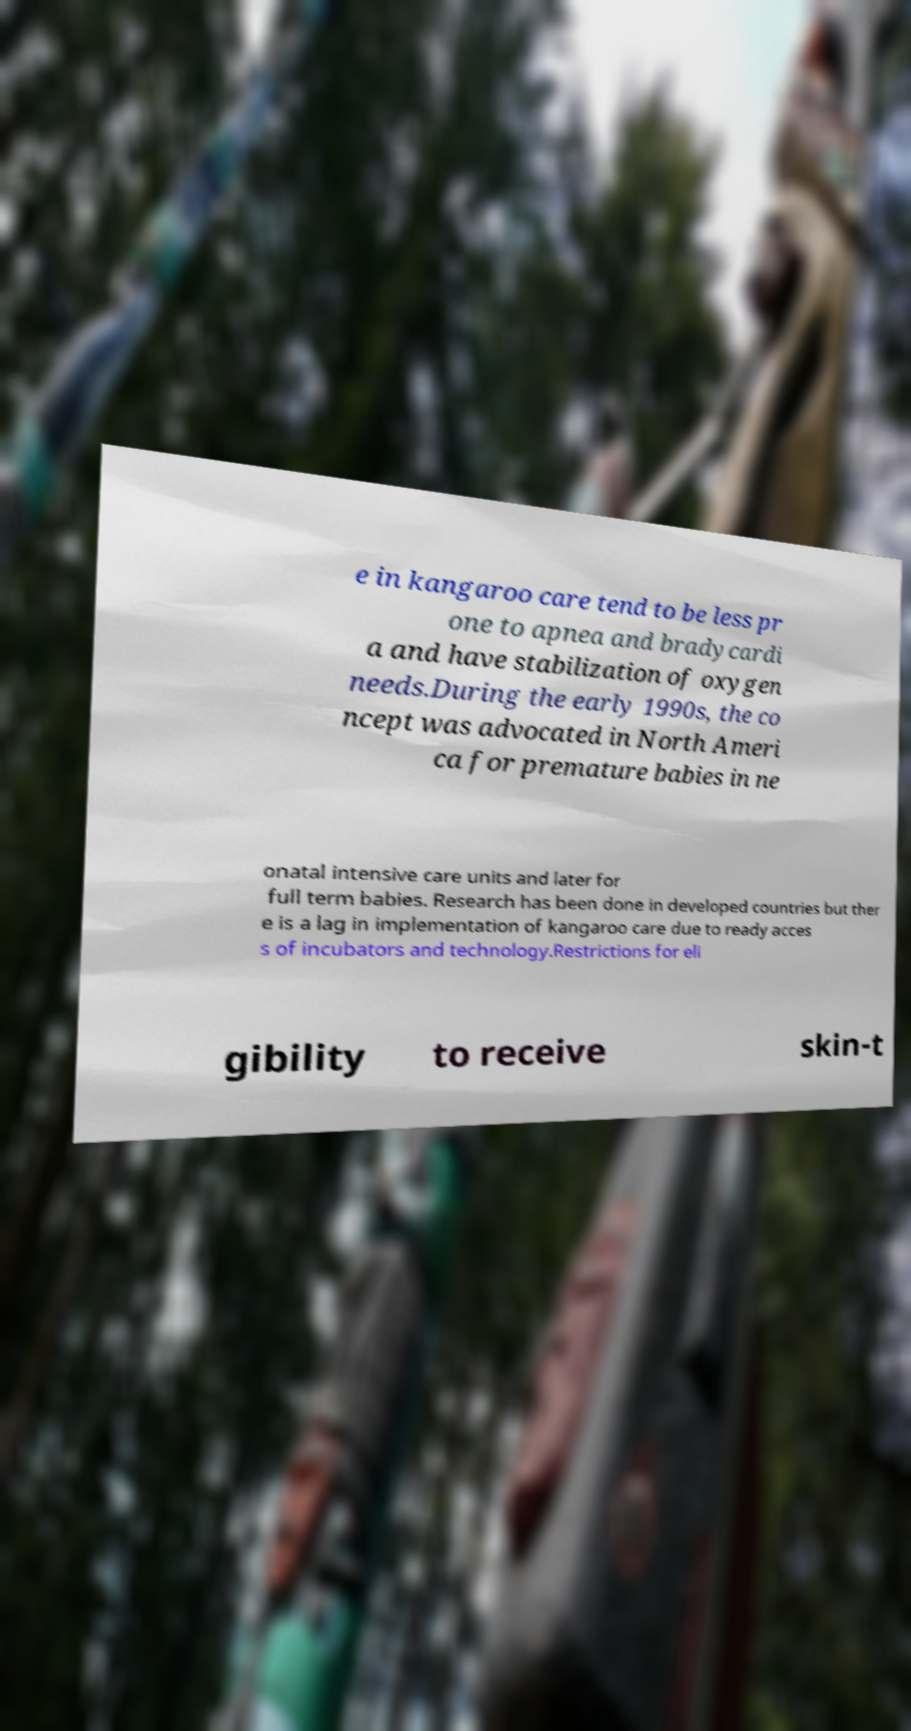Please read and relay the text visible in this image. What does it say? e in kangaroo care tend to be less pr one to apnea and bradycardi a and have stabilization of oxygen needs.During the early 1990s, the co ncept was advocated in North Ameri ca for premature babies in ne onatal intensive care units and later for full term babies. Research has been done in developed countries but ther e is a lag in implementation of kangaroo care due to ready acces s of incubators and technology.Restrictions for eli gibility to receive skin-t 